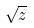Convert formula to latex. <formula><loc_0><loc_0><loc_500><loc_500>\sqrt { z }</formula> 